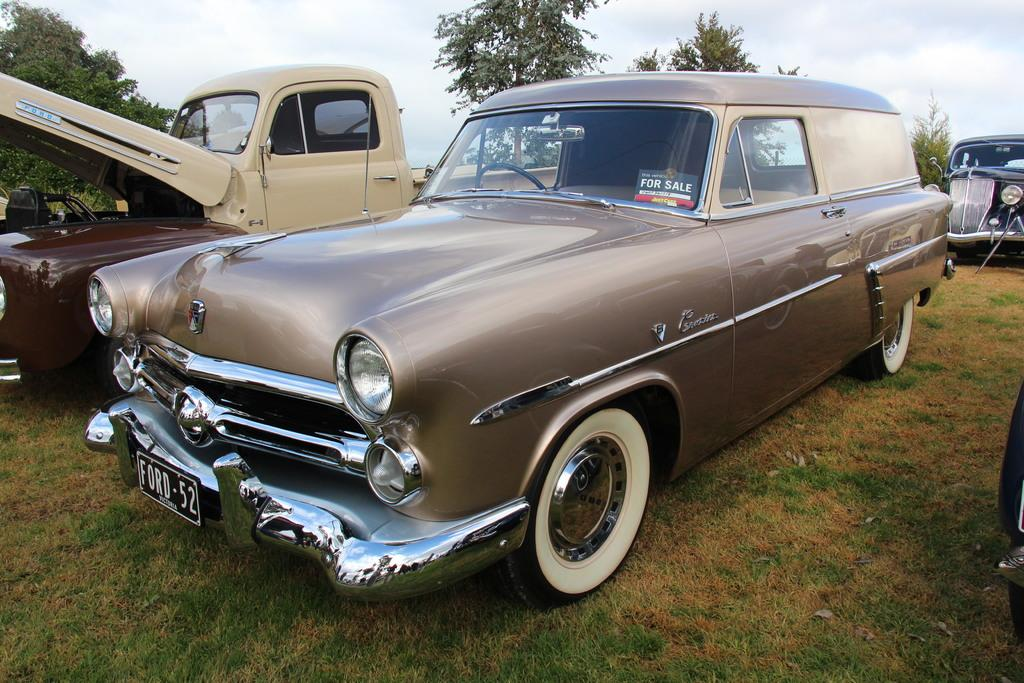<image>
Create a compact narrative representing the image presented. The front of a bronze colored classic car wit ha for sale sign on the front window. 